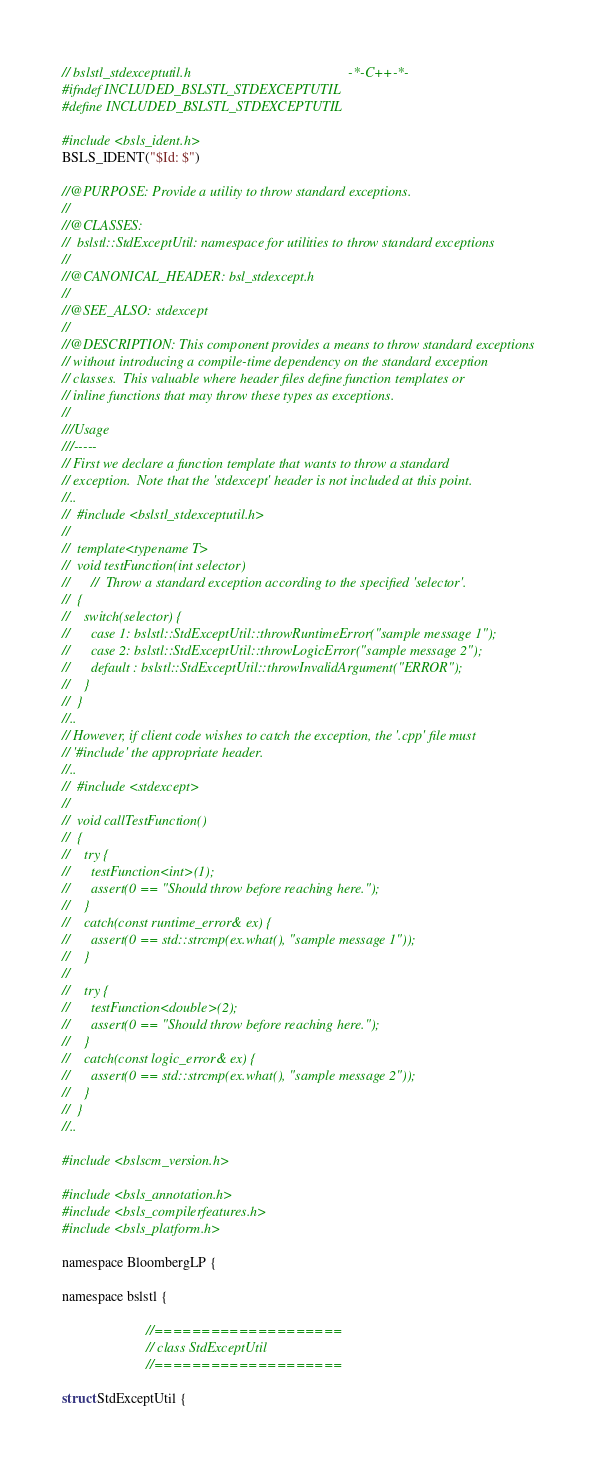Convert code to text. <code><loc_0><loc_0><loc_500><loc_500><_C_>// bslstl_stdexceptutil.h                                             -*-C++-*-
#ifndef INCLUDED_BSLSTL_STDEXCEPTUTIL
#define INCLUDED_BSLSTL_STDEXCEPTUTIL

#include <bsls_ident.h>
BSLS_IDENT("$Id: $")

//@PURPOSE: Provide a utility to throw standard exceptions.
//
//@CLASSES:
//  bslstl::StdExceptUtil: namespace for utilities to throw standard exceptions
//
//@CANONICAL_HEADER: bsl_stdexcept.h
//
//@SEE_ALSO: stdexcept
//
//@DESCRIPTION: This component provides a means to throw standard exceptions
// without introducing a compile-time dependency on the standard exception
// classes.  This valuable where header files define function templates or
// inline functions that may throw these types as exceptions.
//
///Usage
///-----
// First we declare a function template that wants to throw a standard
// exception.  Note that the 'stdexcept' header is not included at this point.
//..
//  #include <bslstl_stdexceptutil.h>
//
//  template<typename T>
//  void testFunction(int selector)
//      //  Throw a standard exception according to the specified 'selector'.
//  {
//    switch(selector) {
//      case 1: bslstl::StdExceptUtil::throwRuntimeError("sample message 1");
//      case 2: bslstl::StdExceptUtil::throwLogicError("sample message 2");
//      default : bslstl::StdExceptUtil::throwInvalidArgument("ERROR");
//    }
//  }
//..
// However, if client code wishes to catch the exception, the '.cpp' file must
// '#include' the appropriate header.
//..
//  #include <stdexcept>
//
//  void callTestFunction()
//  {
//    try {
//      testFunction<int>(1);
//      assert(0 == "Should throw before reaching here.");
//    }
//    catch(const runtime_error& ex) {
//      assert(0 == std::strcmp(ex.what(), "sample message 1"));
//    }
//
//    try {
//      testFunction<double>(2);
//      assert(0 == "Should throw before reaching here.");
//    }
//    catch(const logic_error& ex) {
//      assert(0 == std::strcmp(ex.what(), "sample message 2"));
//    }
//  }
//..

#include <bslscm_version.h>

#include <bsls_annotation.h>
#include <bsls_compilerfeatures.h>
#include <bsls_platform.h>

namespace BloombergLP {

namespace bslstl {

                        //====================
                        // class StdExceptUtil
                        //====================

struct StdExceptUtil {</code> 